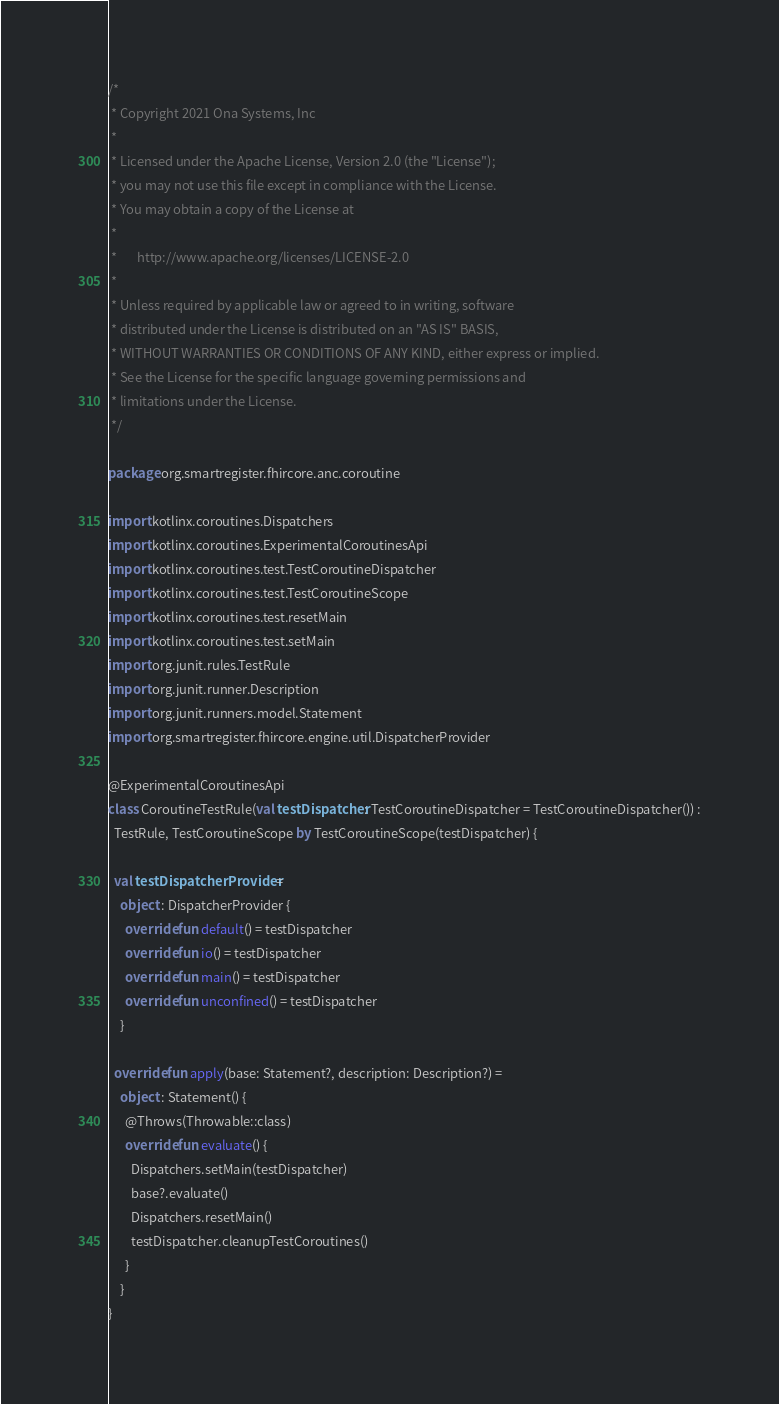<code> <loc_0><loc_0><loc_500><loc_500><_Kotlin_>/*
 * Copyright 2021 Ona Systems, Inc
 *
 * Licensed under the Apache License, Version 2.0 (the "License");
 * you may not use this file except in compliance with the License.
 * You may obtain a copy of the License at
 *
 *       http://www.apache.org/licenses/LICENSE-2.0
 *
 * Unless required by applicable law or agreed to in writing, software
 * distributed under the License is distributed on an "AS IS" BASIS,
 * WITHOUT WARRANTIES OR CONDITIONS OF ANY KIND, either express or implied.
 * See the License for the specific language governing permissions and
 * limitations under the License.
 */

package org.smartregister.fhircore.anc.coroutine

import kotlinx.coroutines.Dispatchers
import kotlinx.coroutines.ExperimentalCoroutinesApi
import kotlinx.coroutines.test.TestCoroutineDispatcher
import kotlinx.coroutines.test.TestCoroutineScope
import kotlinx.coroutines.test.resetMain
import kotlinx.coroutines.test.setMain
import org.junit.rules.TestRule
import org.junit.runner.Description
import org.junit.runners.model.Statement
import org.smartregister.fhircore.engine.util.DispatcherProvider

@ExperimentalCoroutinesApi
class CoroutineTestRule(val testDispatcher: TestCoroutineDispatcher = TestCoroutineDispatcher()) :
  TestRule, TestCoroutineScope by TestCoroutineScope(testDispatcher) {

  val testDispatcherProvider =
    object : DispatcherProvider {
      override fun default() = testDispatcher
      override fun io() = testDispatcher
      override fun main() = testDispatcher
      override fun unconfined() = testDispatcher
    }

  override fun apply(base: Statement?, description: Description?) =
    object : Statement() {
      @Throws(Throwable::class)
      override fun evaluate() {
        Dispatchers.setMain(testDispatcher)
        base?.evaluate()
        Dispatchers.resetMain()
        testDispatcher.cleanupTestCoroutines()
      }
    }
}
</code> 